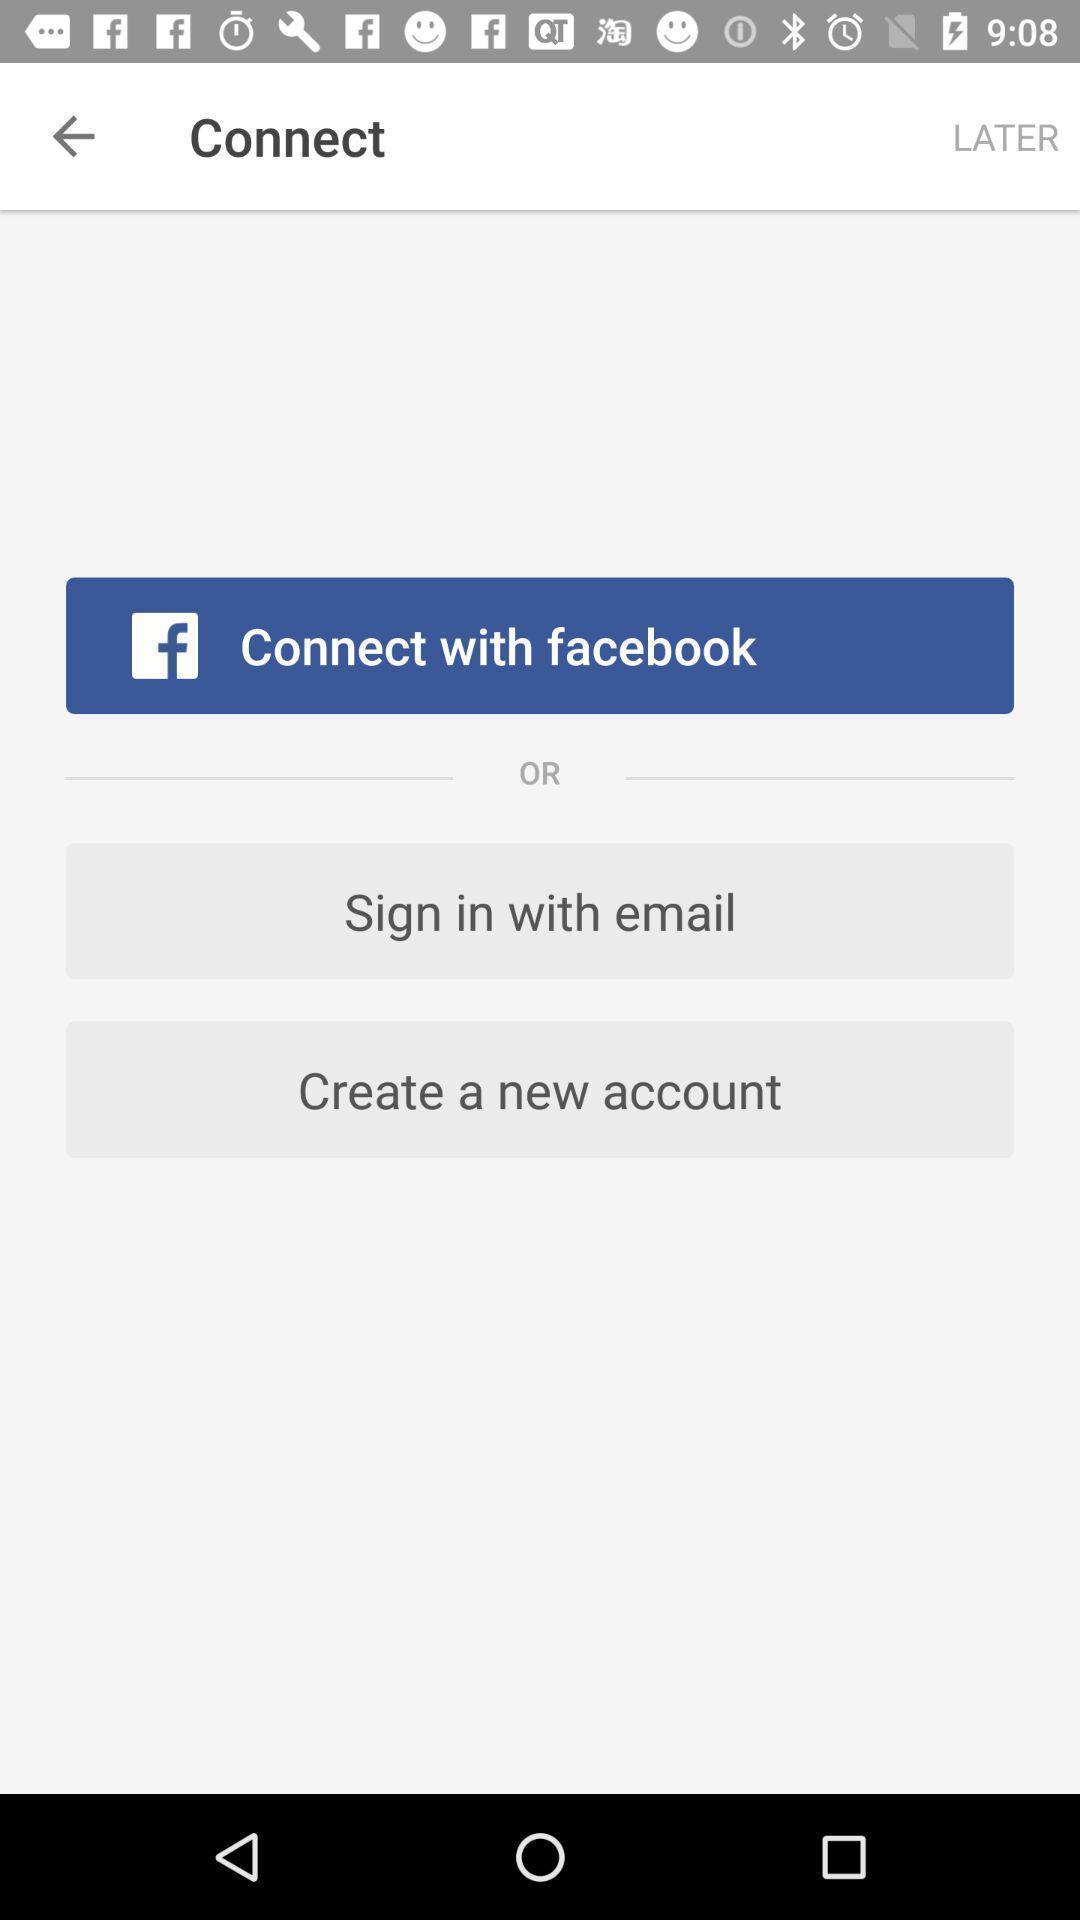Provide a detailed account of this screenshot. Sign in/sign up page. 